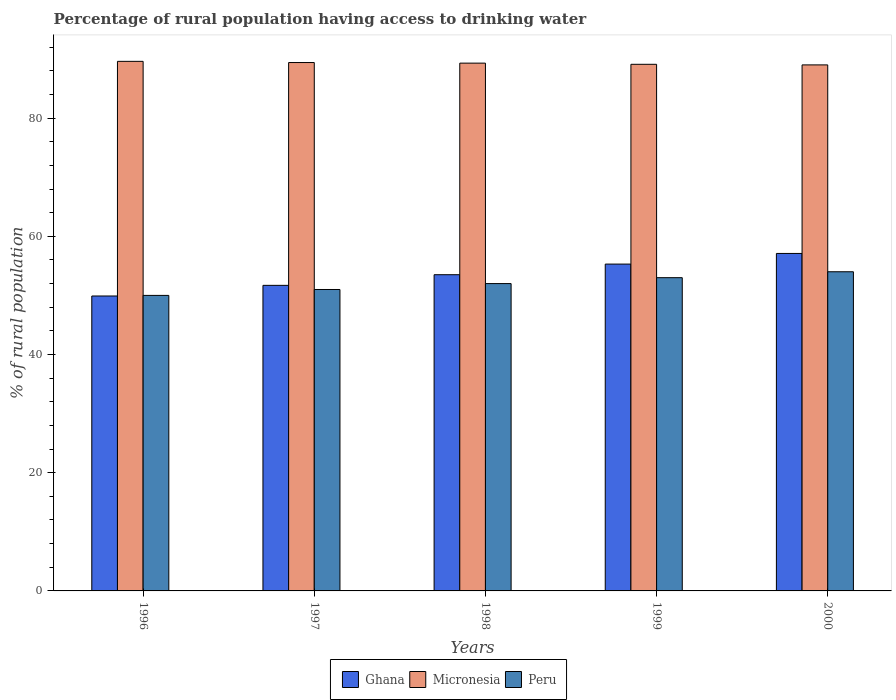How many different coloured bars are there?
Provide a succinct answer. 3. How many groups of bars are there?
Keep it short and to the point. 5. How many bars are there on the 3rd tick from the right?
Offer a terse response. 3. What is the label of the 1st group of bars from the left?
Keep it short and to the point. 1996. In how many cases, is the number of bars for a given year not equal to the number of legend labels?
Keep it short and to the point. 0. What is the percentage of rural population having access to drinking water in Ghana in 2000?
Your response must be concise. 57.1. Across all years, what is the minimum percentage of rural population having access to drinking water in Micronesia?
Provide a short and direct response. 89. In which year was the percentage of rural population having access to drinking water in Ghana maximum?
Your answer should be compact. 2000. What is the total percentage of rural population having access to drinking water in Ghana in the graph?
Provide a succinct answer. 267.5. What is the difference between the percentage of rural population having access to drinking water in Ghana in 1999 and that in 2000?
Provide a short and direct response. -1.8. What is the average percentage of rural population having access to drinking water in Ghana per year?
Your answer should be compact. 53.5. In the year 2000, what is the difference between the percentage of rural population having access to drinking water in Micronesia and percentage of rural population having access to drinking water in Ghana?
Your response must be concise. 31.9. What is the ratio of the percentage of rural population having access to drinking water in Micronesia in 1996 to that in 1998?
Your answer should be compact. 1. Is the percentage of rural population having access to drinking water in Micronesia in 1998 less than that in 1999?
Provide a short and direct response. No. What is the difference between the highest and the second highest percentage of rural population having access to drinking water in Ghana?
Your answer should be very brief. 1.8. What is the difference between the highest and the lowest percentage of rural population having access to drinking water in Ghana?
Provide a short and direct response. 7.2. In how many years, is the percentage of rural population having access to drinking water in Ghana greater than the average percentage of rural population having access to drinking water in Ghana taken over all years?
Your answer should be compact. 2. What does the 3rd bar from the left in 1999 represents?
Keep it short and to the point. Peru. What does the 2nd bar from the right in 1997 represents?
Your answer should be compact. Micronesia. Is it the case that in every year, the sum of the percentage of rural population having access to drinking water in Ghana and percentage of rural population having access to drinking water in Micronesia is greater than the percentage of rural population having access to drinking water in Peru?
Provide a succinct answer. Yes. How many bars are there?
Ensure brevity in your answer.  15. What is the difference between two consecutive major ticks on the Y-axis?
Offer a terse response. 20. Does the graph contain any zero values?
Your response must be concise. No. Does the graph contain grids?
Your answer should be very brief. No. Where does the legend appear in the graph?
Ensure brevity in your answer.  Bottom center. How many legend labels are there?
Your response must be concise. 3. What is the title of the graph?
Offer a very short reply. Percentage of rural population having access to drinking water. Does "Somalia" appear as one of the legend labels in the graph?
Your answer should be compact. No. What is the label or title of the Y-axis?
Offer a very short reply. % of rural population. What is the % of rural population in Ghana in 1996?
Your answer should be very brief. 49.9. What is the % of rural population of Micronesia in 1996?
Give a very brief answer. 89.6. What is the % of rural population in Ghana in 1997?
Your answer should be compact. 51.7. What is the % of rural population in Micronesia in 1997?
Offer a terse response. 89.4. What is the % of rural population of Ghana in 1998?
Provide a short and direct response. 53.5. What is the % of rural population in Micronesia in 1998?
Provide a short and direct response. 89.3. What is the % of rural population in Peru in 1998?
Provide a short and direct response. 52. What is the % of rural population in Ghana in 1999?
Your response must be concise. 55.3. What is the % of rural population of Micronesia in 1999?
Give a very brief answer. 89.1. What is the % of rural population in Peru in 1999?
Ensure brevity in your answer.  53. What is the % of rural population of Ghana in 2000?
Give a very brief answer. 57.1. What is the % of rural population of Micronesia in 2000?
Give a very brief answer. 89. Across all years, what is the maximum % of rural population in Ghana?
Your answer should be compact. 57.1. Across all years, what is the maximum % of rural population in Micronesia?
Keep it short and to the point. 89.6. Across all years, what is the minimum % of rural population in Ghana?
Offer a very short reply. 49.9. Across all years, what is the minimum % of rural population of Micronesia?
Provide a short and direct response. 89. Across all years, what is the minimum % of rural population of Peru?
Provide a succinct answer. 50. What is the total % of rural population of Ghana in the graph?
Keep it short and to the point. 267.5. What is the total % of rural population of Micronesia in the graph?
Ensure brevity in your answer.  446.4. What is the total % of rural population in Peru in the graph?
Provide a succinct answer. 260. What is the difference between the % of rural population in Ghana in 1996 and that in 1997?
Your response must be concise. -1.8. What is the difference between the % of rural population in Peru in 1996 and that in 1997?
Offer a terse response. -1. What is the difference between the % of rural population in Ghana in 1996 and that in 1998?
Offer a terse response. -3.6. What is the difference between the % of rural population in Ghana in 1996 and that in 1999?
Make the answer very short. -5.4. What is the difference between the % of rural population of Peru in 1996 and that in 2000?
Give a very brief answer. -4. What is the difference between the % of rural population in Ghana in 1997 and that in 1998?
Your answer should be compact. -1.8. What is the difference between the % of rural population of Micronesia in 1997 and that in 1998?
Keep it short and to the point. 0.1. What is the difference between the % of rural population of Micronesia in 1997 and that in 1999?
Give a very brief answer. 0.3. What is the difference between the % of rural population of Peru in 1997 and that in 2000?
Offer a very short reply. -3. What is the difference between the % of rural population in Ghana in 1998 and that in 1999?
Your answer should be very brief. -1.8. What is the difference between the % of rural population in Peru in 1998 and that in 1999?
Provide a short and direct response. -1. What is the difference between the % of rural population of Micronesia in 1998 and that in 2000?
Your response must be concise. 0.3. What is the difference between the % of rural population in Peru in 1998 and that in 2000?
Give a very brief answer. -2. What is the difference between the % of rural population in Ghana in 1999 and that in 2000?
Your answer should be compact. -1.8. What is the difference between the % of rural population of Ghana in 1996 and the % of rural population of Micronesia in 1997?
Provide a succinct answer. -39.5. What is the difference between the % of rural population of Ghana in 1996 and the % of rural population of Peru in 1997?
Give a very brief answer. -1.1. What is the difference between the % of rural population in Micronesia in 1996 and the % of rural population in Peru in 1997?
Your answer should be compact. 38.6. What is the difference between the % of rural population of Ghana in 1996 and the % of rural population of Micronesia in 1998?
Your answer should be very brief. -39.4. What is the difference between the % of rural population of Micronesia in 1996 and the % of rural population of Peru in 1998?
Your response must be concise. 37.6. What is the difference between the % of rural population in Ghana in 1996 and the % of rural population in Micronesia in 1999?
Keep it short and to the point. -39.2. What is the difference between the % of rural population in Ghana in 1996 and the % of rural population in Peru in 1999?
Offer a very short reply. -3.1. What is the difference between the % of rural population in Micronesia in 1996 and the % of rural population in Peru in 1999?
Provide a succinct answer. 36.6. What is the difference between the % of rural population of Ghana in 1996 and the % of rural population of Micronesia in 2000?
Your answer should be very brief. -39.1. What is the difference between the % of rural population in Micronesia in 1996 and the % of rural population in Peru in 2000?
Your response must be concise. 35.6. What is the difference between the % of rural population of Ghana in 1997 and the % of rural population of Micronesia in 1998?
Your answer should be very brief. -37.6. What is the difference between the % of rural population in Ghana in 1997 and the % of rural population in Peru in 1998?
Offer a very short reply. -0.3. What is the difference between the % of rural population in Micronesia in 1997 and the % of rural population in Peru in 1998?
Give a very brief answer. 37.4. What is the difference between the % of rural population in Ghana in 1997 and the % of rural population in Micronesia in 1999?
Offer a very short reply. -37.4. What is the difference between the % of rural population in Ghana in 1997 and the % of rural population in Peru in 1999?
Your answer should be very brief. -1.3. What is the difference between the % of rural population of Micronesia in 1997 and the % of rural population of Peru in 1999?
Give a very brief answer. 36.4. What is the difference between the % of rural population in Ghana in 1997 and the % of rural population in Micronesia in 2000?
Your response must be concise. -37.3. What is the difference between the % of rural population in Micronesia in 1997 and the % of rural population in Peru in 2000?
Make the answer very short. 35.4. What is the difference between the % of rural population in Ghana in 1998 and the % of rural population in Micronesia in 1999?
Provide a short and direct response. -35.6. What is the difference between the % of rural population of Micronesia in 1998 and the % of rural population of Peru in 1999?
Provide a succinct answer. 36.3. What is the difference between the % of rural population in Ghana in 1998 and the % of rural population in Micronesia in 2000?
Your answer should be compact. -35.5. What is the difference between the % of rural population of Ghana in 1998 and the % of rural population of Peru in 2000?
Make the answer very short. -0.5. What is the difference between the % of rural population of Micronesia in 1998 and the % of rural population of Peru in 2000?
Offer a terse response. 35.3. What is the difference between the % of rural population in Ghana in 1999 and the % of rural population in Micronesia in 2000?
Give a very brief answer. -33.7. What is the difference between the % of rural population of Ghana in 1999 and the % of rural population of Peru in 2000?
Give a very brief answer. 1.3. What is the difference between the % of rural population of Micronesia in 1999 and the % of rural population of Peru in 2000?
Keep it short and to the point. 35.1. What is the average % of rural population in Ghana per year?
Ensure brevity in your answer.  53.5. What is the average % of rural population of Micronesia per year?
Offer a terse response. 89.28. In the year 1996, what is the difference between the % of rural population of Ghana and % of rural population of Micronesia?
Offer a terse response. -39.7. In the year 1996, what is the difference between the % of rural population of Micronesia and % of rural population of Peru?
Keep it short and to the point. 39.6. In the year 1997, what is the difference between the % of rural population in Ghana and % of rural population in Micronesia?
Provide a succinct answer. -37.7. In the year 1997, what is the difference between the % of rural population of Micronesia and % of rural population of Peru?
Provide a succinct answer. 38.4. In the year 1998, what is the difference between the % of rural population of Ghana and % of rural population of Micronesia?
Provide a short and direct response. -35.8. In the year 1998, what is the difference between the % of rural population of Ghana and % of rural population of Peru?
Make the answer very short. 1.5. In the year 1998, what is the difference between the % of rural population of Micronesia and % of rural population of Peru?
Offer a terse response. 37.3. In the year 1999, what is the difference between the % of rural population in Ghana and % of rural population in Micronesia?
Offer a terse response. -33.8. In the year 1999, what is the difference between the % of rural population in Micronesia and % of rural population in Peru?
Ensure brevity in your answer.  36.1. In the year 2000, what is the difference between the % of rural population of Ghana and % of rural population of Micronesia?
Ensure brevity in your answer.  -31.9. What is the ratio of the % of rural population of Ghana in 1996 to that in 1997?
Provide a short and direct response. 0.97. What is the ratio of the % of rural population of Peru in 1996 to that in 1997?
Offer a terse response. 0.98. What is the ratio of the % of rural population in Ghana in 1996 to that in 1998?
Offer a very short reply. 0.93. What is the ratio of the % of rural population of Micronesia in 1996 to that in 1998?
Your response must be concise. 1. What is the ratio of the % of rural population in Peru in 1996 to that in 1998?
Ensure brevity in your answer.  0.96. What is the ratio of the % of rural population of Ghana in 1996 to that in 1999?
Keep it short and to the point. 0.9. What is the ratio of the % of rural population in Micronesia in 1996 to that in 1999?
Offer a very short reply. 1.01. What is the ratio of the % of rural population in Peru in 1996 to that in 1999?
Offer a terse response. 0.94. What is the ratio of the % of rural population in Ghana in 1996 to that in 2000?
Offer a very short reply. 0.87. What is the ratio of the % of rural population in Micronesia in 1996 to that in 2000?
Offer a terse response. 1.01. What is the ratio of the % of rural population in Peru in 1996 to that in 2000?
Keep it short and to the point. 0.93. What is the ratio of the % of rural population of Ghana in 1997 to that in 1998?
Provide a short and direct response. 0.97. What is the ratio of the % of rural population of Peru in 1997 to that in 1998?
Provide a succinct answer. 0.98. What is the ratio of the % of rural population of Ghana in 1997 to that in 1999?
Offer a very short reply. 0.93. What is the ratio of the % of rural population of Micronesia in 1997 to that in 1999?
Keep it short and to the point. 1. What is the ratio of the % of rural population of Peru in 1997 to that in 1999?
Provide a succinct answer. 0.96. What is the ratio of the % of rural population of Ghana in 1997 to that in 2000?
Your answer should be very brief. 0.91. What is the ratio of the % of rural population in Micronesia in 1997 to that in 2000?
Your answer should be compact. 1. What is the ratio of the % of rural population of Ghana in 1998 to that in 1999?
Offer a terse response. 0.97. What is the ratio of the % of rural population in Micronesia in 1998 to that in 1999?
Provide a short and direct response. 1. What is the ratio of the % of rural population in Peru in 1998 to that in 1999?
Give a very brief answer. 0.98. What is the ratio of the % of rural population in Ghana in 1998 to that in 2000?
Make the answer very short. 0.94. What is the ratio of the % of rural population in Ghana in 1999 to that in 2000?
Offer a very short reply. 0.97. What is the ratio of the % of rural population in Micronesia in 1999 to that in 2000?
Your answer should be very brief. 1. What is the ratio of the % of rural population of Peru in 1999 to that in 2000?
Make the answer very short. 0.98. What is the difference between the highest and the second highest % of rural population of Peru?
Keep it short and to the point. 1. What is the difference between the highest and the lowest % of rural population of Ghana?
Offer a terse response. 7.2. What is the difference between the highest and the lowest % of rural population of Peru?
Provide a short and direct response. 4. 